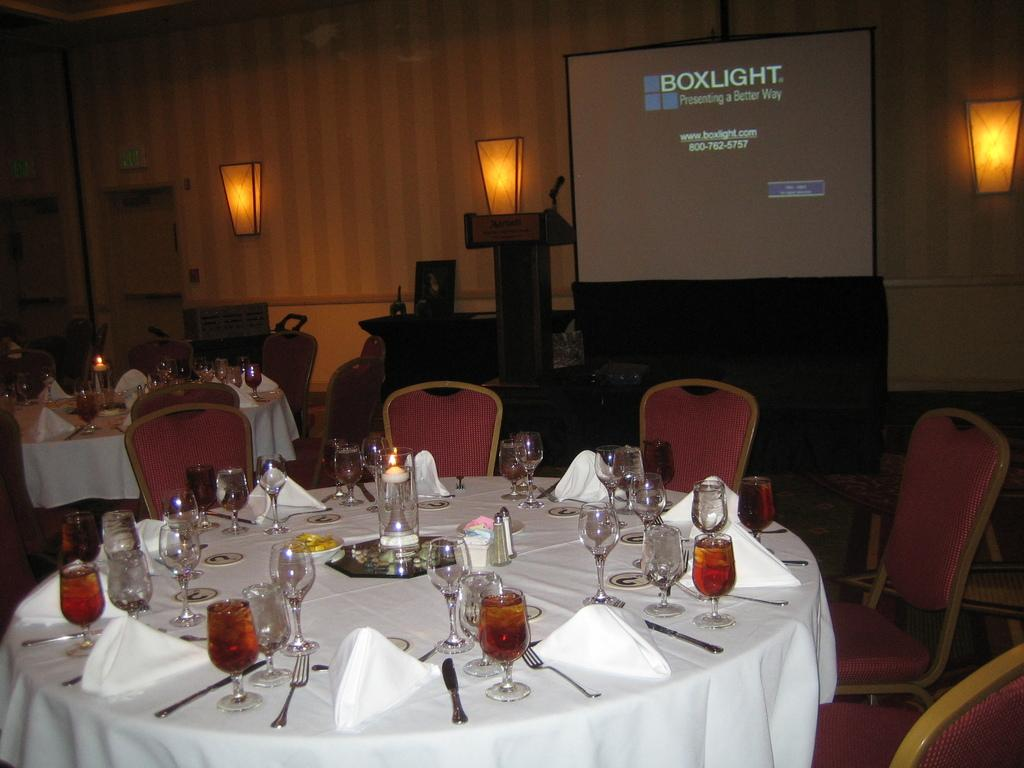<image>
Create a compact narrative representing the image presented. Dinner tables set up in front of a screen that says Boxlight on it. 